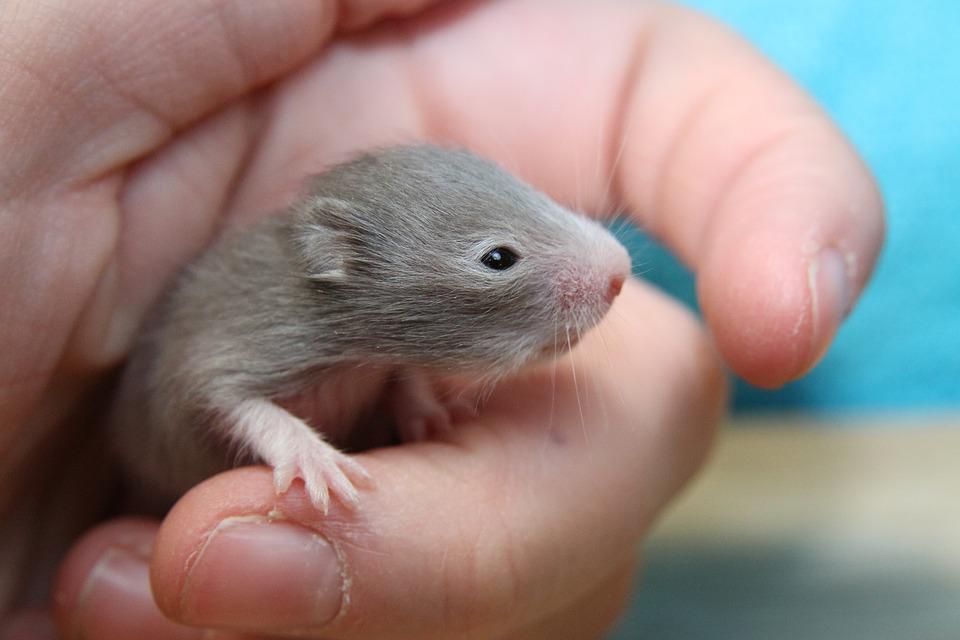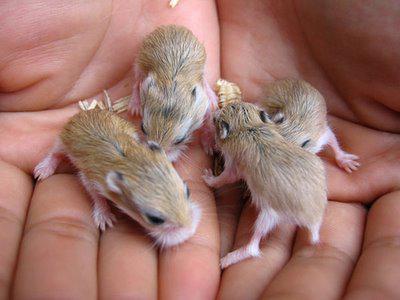The first image is the image on the left, the second image is the image on the right. Evaluate the accuracy of this statement regarding the images: "In each image, one hand is palm up holding one pet rodent.". Is it true? Answer yes or no. No. 